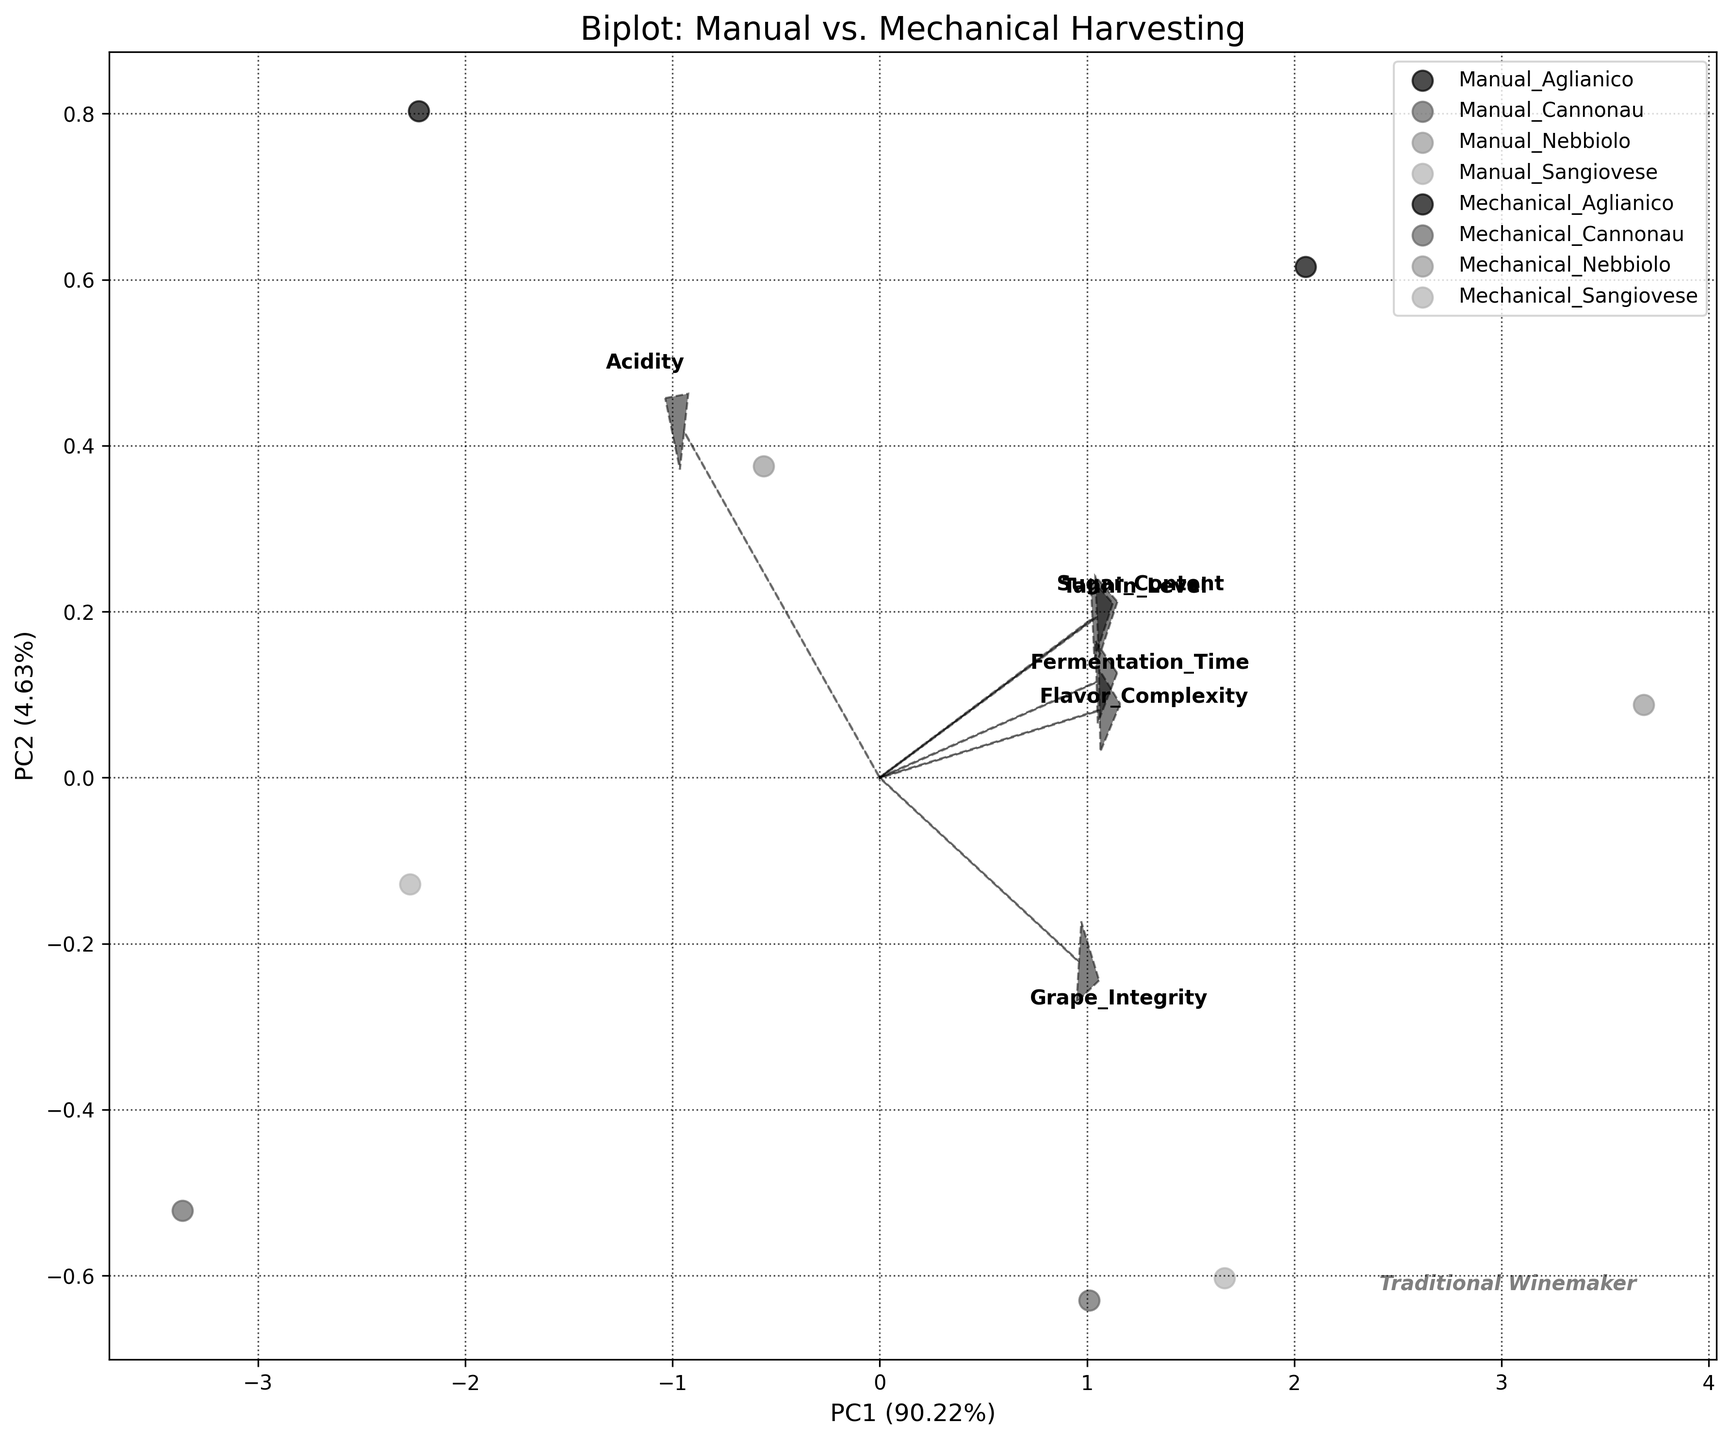What is the title of the biplot? The title of a plot can usually be found at the top. This plot's title will be written clearly to describe what the data and analysis are about.
Answer: Biplot: Manual vs. Mechanical Harvesting How many different harvesting methods are compared in the biplot? Look at the legend or the plot to count the distinct groups being compared. Each harvesting method forms a different group in the legend.
Answer: Two What are the axis labels for PC1 and PC2? The axis labels describe the principal components and often include the percentage of variance explained by each. These labels are typically found next to the respective axes.
Answer: PC1 and PC2 Which harvesting method showed better grape integrity? Identify the data points representing grape integrity for both methods and compare their positions relative to the aggregate loading vectors.
Answer: Manual Which variables have the highest loading on PC1? Look at the arrows representing the variable loadings. The variable with the longest arrow aligned closely with PC1 has the highest loading on it.
Answer: Grape Integrity and Sugar Content How do manual and mechanical harvesting scores compare for Sangiovese on PC1? Examine the scores for manual Sangiovese and mechanical Sangiovese on the PC1 axis by noting their positions on the horizontal axis.
Answer: Manual is higher Which grape variety shows the most significant difference between manual and mechanical harvesting on PC2? Compare the data points of each grape variety for both harvesting methods along the PC2 axis to see which pair has the largest difference.
Answer: Cannonau How do the fermentation times cluster together or separate along the principal components? Identify how the data points are distributed along PC1 and PC2, then assess the relative positions of fermentation times.
Answer: They do not cluster distinctly by fermentation time Are manual and mechanical harvesting methods more distinguishable on PC1 or PC2? Compare the spread and separation of data points for both methods along each principal component axis to determine where they are more distinguishable.
Answer: PC1 